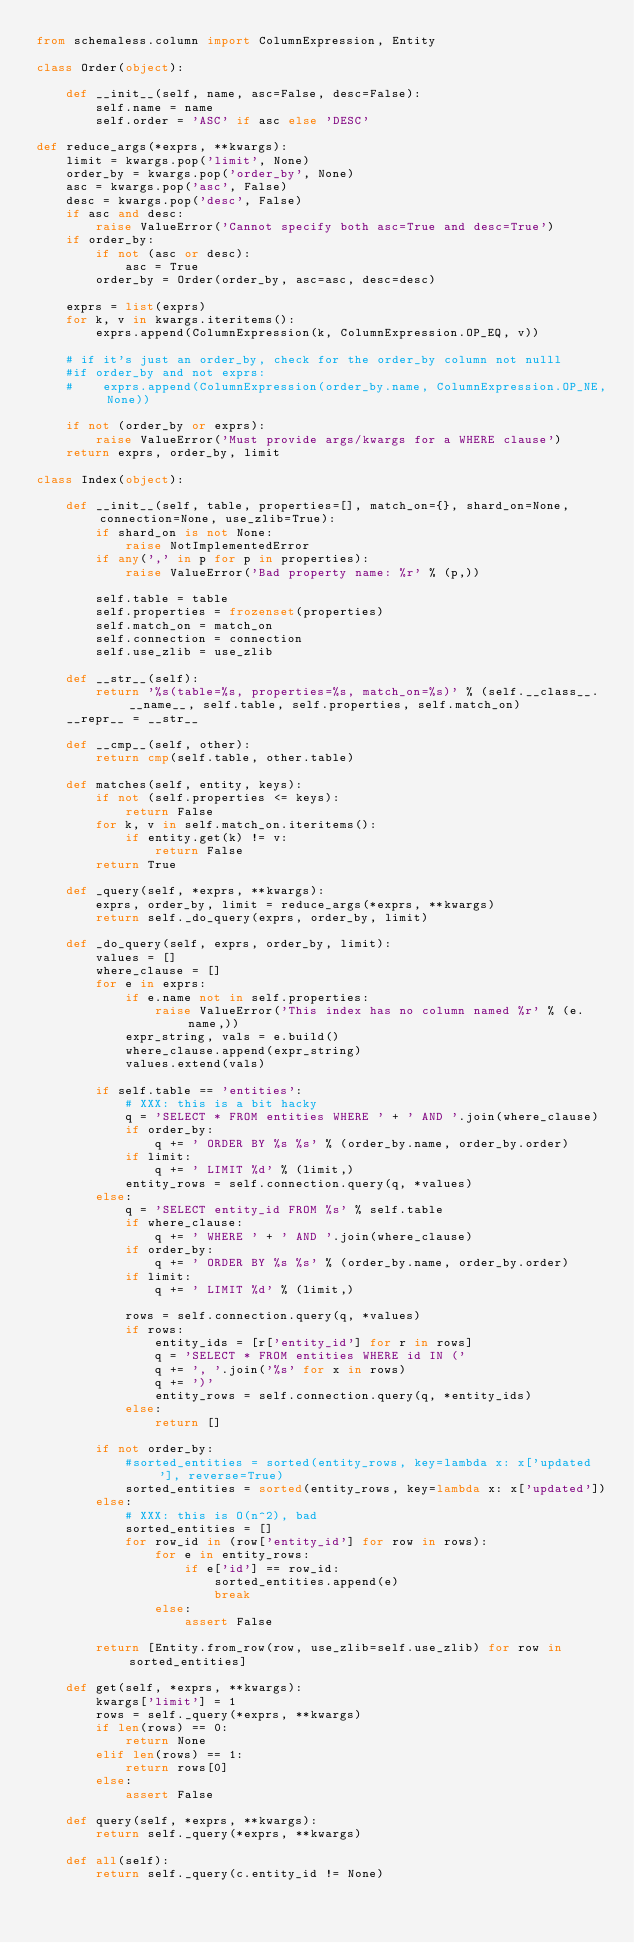Convert code to text. <code><loc_0><loc_0><loc_500><loc_500><_Python_>from schemaless.column import ColumnExpression, Entity

class Order(object):

    def __init__(self, name, asc=False, desc=False):
        self.name = name
        self.order = 'ASC' if asc else 'DESC'

def reduce_args(*exprs, **kwargs):
    limit = kwargs.pop('limit', None)
    order_by = kwargs.pop('order_by', None)
    asc = kwargs.pop('asc', False)
    desc = kwargs.pop('desc', False)
    if asc and desc:
        raise ValueError('Cannot specify both asc=True and desc=True')
    if order_by:
        if not (asc or desc):
            asc = True
        order_by = Order(order_by, asc=asc, desc=desc)

    exprs = list(exprs)
    for k, v in kwargs.iteritems():
        exprs.append(ColumnExpression(k, ColumnExpression.OP_EQ, v))

    # if it's just an order_by, check for the order_by column not nulll
    #if order_by and not exprs:
    #    exprs.append(ColumnExpression(order_by.name, ColumnExpression.OP_NE, None))

    if not (order_by or exprs):
        raise ValueError('Must provide args/kwargs for a WHERE clause')
    return exprs, order_by, limit

class Index(object):

    def __init__(self, table, properties=[], match_on={}, shard_on=None, connection=None, use_zlib=True):
        if shard_on is not None:
            raise NotImplementedError
        if any(',' in p for p in properties):
            raise ValueError('Bad property name: %r' % (p,))

        self.table = table
        self.properties = frozenset(properties)
        self.match_on = match_on
        self.connection = connection
        self.use_zlib = use_zlib

    def __str__(self):
        return '%s(table=%s, properties=%s, match_on=%s)' % (self.__class__.__name__, self.table, self.properties, self.match_on)
    __repr__ = __str__

    def __cmp__(self, other):
        return cmp(self.table, other.table)

    def matches(self, entity, keys):
        if not (self.properties <= keys):
            return False
        for k, v in self.match_on.iteritems():
            if entity.get(k) != v:
                return False
        return True

    def _query(self, *exprs, **kwargs):
        exprs, order_by, limit = reduce_args(*exprs, **kwargs)
        return self._do_query(exprs, order_by, limit)

    def _do_query(self, exprs, order_by, limit):
        values = []
        where_clause = []
        for e in exprs:
            if e.name not in self.properties:
                raise ValueError('This index has no column named %r' % (e.name,))
            expr_string, vals = e.build()
            where_clause.append(expr_string)
            values.extend(vals)

        if self.table == 'entities':
            # XXX: this is a bit hacky
            q = 'SELECT * FROM entities WHERE ' + ' AND '.join(where_clause)
            if order_by:
                q += ' ORDER BY %s %s' % (order_by.name, order_by.order)
            if limit:
                q += ' LIMIT %d' % (limit,)
            entity_rows = self.connection.query(q, *values)
        else:
            q = 'SELECT entity_id FROM %s' % self.table
            if where_clause:
                q += ' WHERE ' + ' AND '.join(where_clause)
            if order_by:
                q += ' ORDER BY %s %s' % (order_by.name, order_by.order)
            if limit:
                q += ' LIMIT %d' % (limit,)

            rows = self.connection.query(q, *values)
            if rows:
                entity_ids = [r['entity_id'] for r in rows]
                q = 'SELECT * FROM entities WHERE id IN ('
                q += ', '.join('%s' for x in rows)
                q += ')'
                entity_rows = self.connection.query(q, *entity_ids)
            else:
                return []

        if not order_by:
            #sorted_entities = sorted(entity_rows, key=lambda x: x['updated'], reverse=True)
            sorted_entities = sorted(entity_rows, key=lambda x: x['updated'])
        else:
            # XXX: this is O(n^2), bad
            sorted_entities = []
            for row_id in (row['entity_id'] for row in rows):
                for e in entity_rows:
                    if e['id'] == row_id:
                        sorted_entities.append(e)
                        break
                else:
                    assert False

        return [Entity.from_row(row, use_zlib=self.use_zlib) for row in sorted_entities]

    def get(self, *exprs, **kwargs):
        kwargs['limit'] = 1
        rows = self._query(*exprs, **kwargs)
        if len(rows) == 0:
            return None
        elif len(rows) == 1:
            return rows[0]
        else:
            assert False

    def query(self, *exprs, **kwargs):
        return self._query(*exprs, **kwargs)

    def all(self):
        return self._query(c.entity_id != None)
</code> 